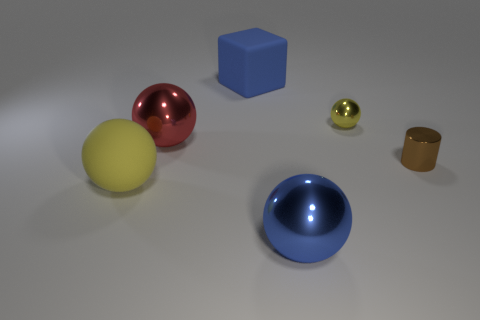There is a metal thing that is both behind the large blue metallic sphere and left of the small yellow metal sphere; what is its shape?
Keep it short and to the point. Sphere. How many tiny objects are cyan cubes or cubes?
Provide a short and direct response. 0. What material is the small cylinder?
Make the answer very short. Metal. How many other objects are the same shape as the tiny yellow shiny object?
Ensure brevity in your answer.  3. The red object has what size?
Provide a short and direct response. Large. What size is the ball that is both behind the big blue shiny sphere and right of the large red shiny object?
Ensure brevity in your answer.  Small. What shape is the big metal thing behind the tiny brown metal cylinder?
Keep it short and to the point. Sphere. Do the red object and the blue thing in front of the small yellow metal object have the same material?
Provide a succinct answer. Yes. Is the shape of the red shiny thing the same as the brown thing?
Keep it short and to the point. No. What is the material of the other yellow thing that is the same shape as the small yellow shiny object?
Your response must be concise. Rubber. 